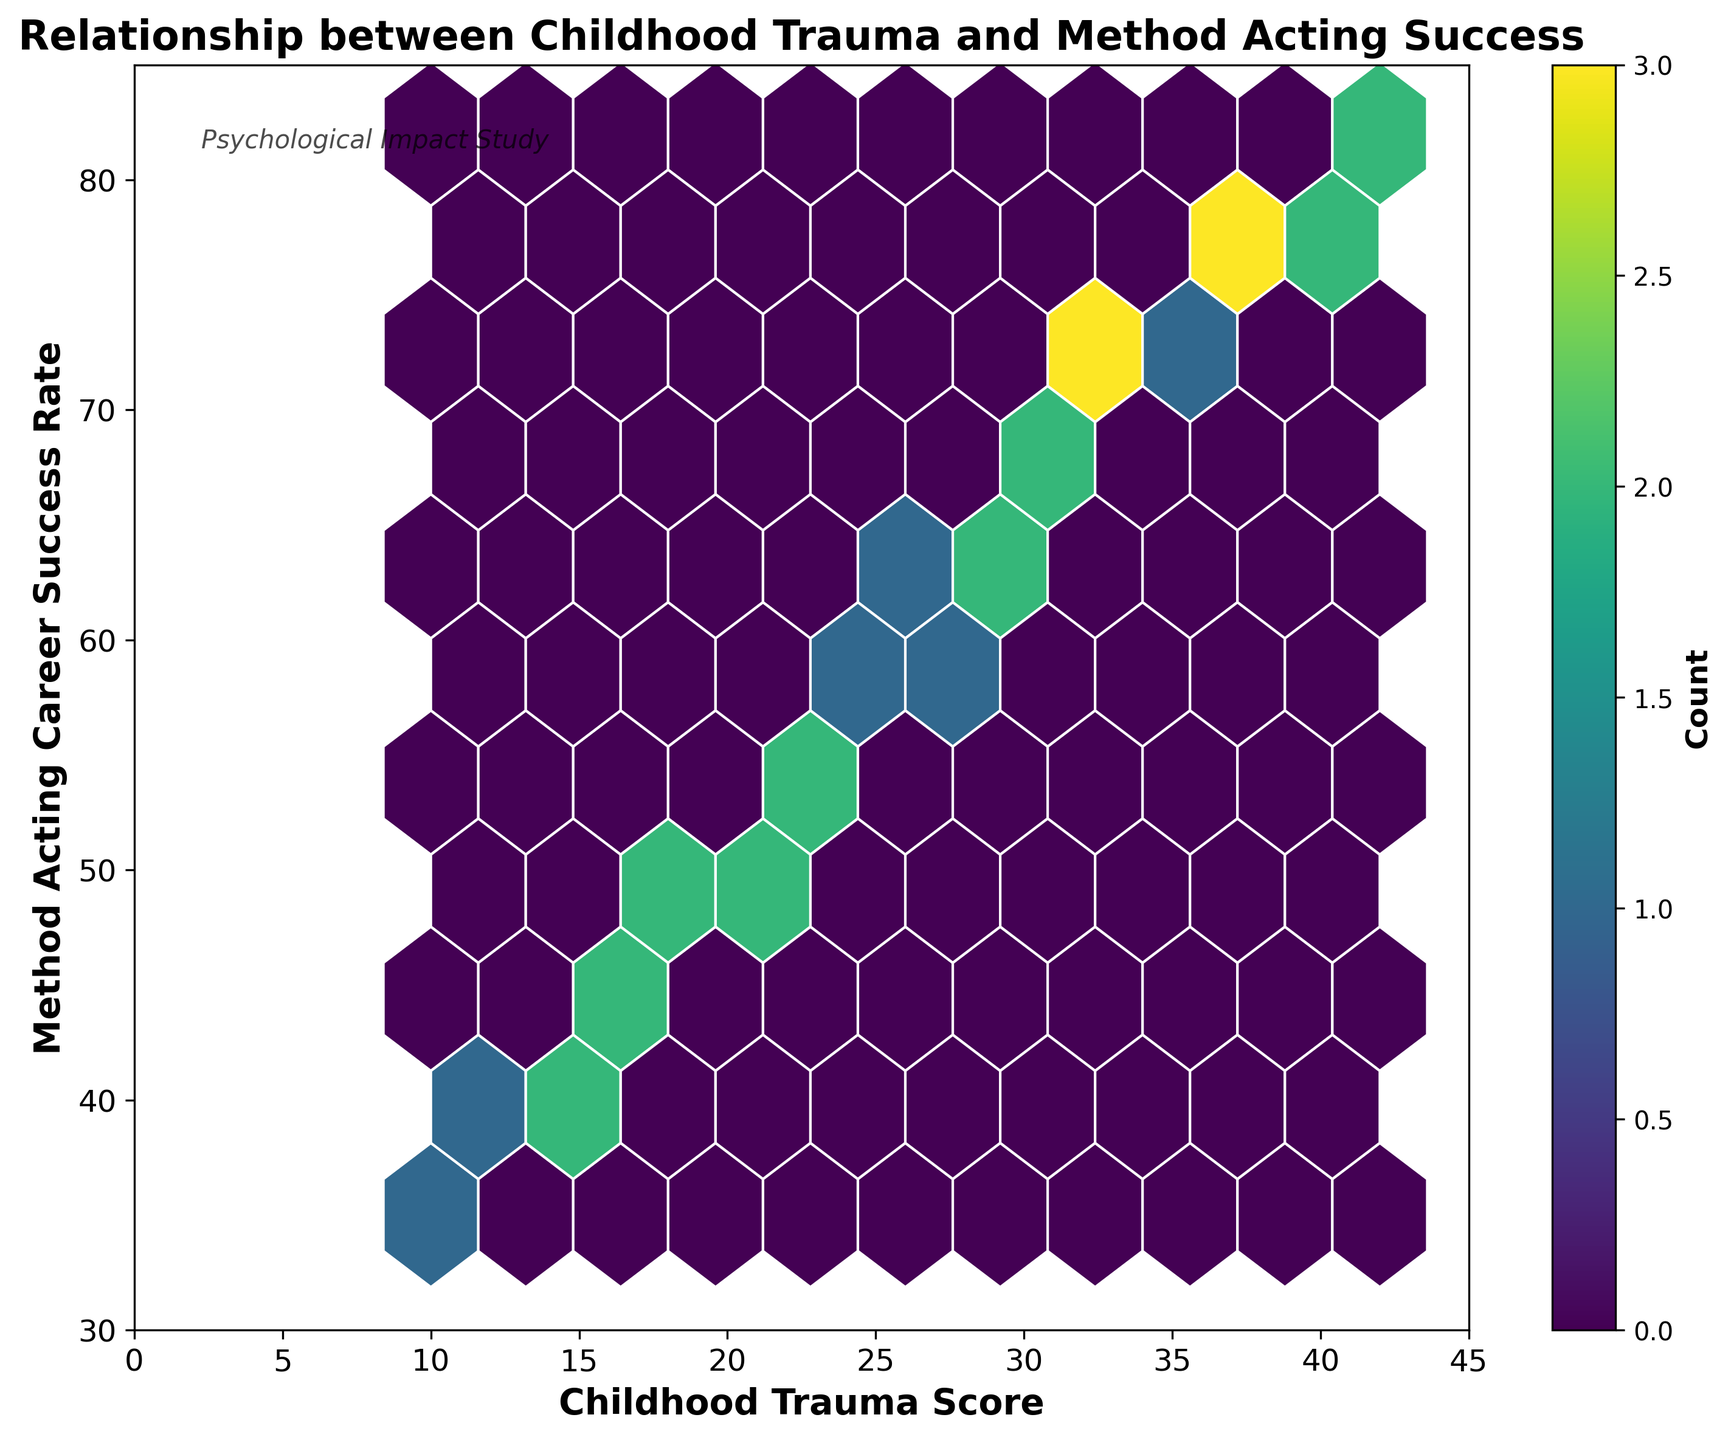What is the title of the figure? The title is displayed at the top of the figure. It gives an overview of what the plot represents.
Answer: Relationship between Childhood Trauma and Method Acting Success What color is used in the hexbin plot to show higher densities of data points? The hexbin plot uses a color gradient where darker colors indicate higher densities. In this plot, the color transitions from lighter to darker shades of green, with the darkest areas showing the highest densities.
Answer: Dark green What is the range of Childhood Trauma Scores on the x-axis? The x-axis labels indicate the range of values for Childhood Trauma Scores that the plot covers. The axis starts at 0 and ends at 45, as shown by the tick marks.
Answer: 0 to 45 Where on the plot do the highest densities of data points appear? By looking at the darkest colored hexagons on the plot, we can identify areas of the plot where data points are most concentrated. These are around the middle values of Childhood Trauma Scores and Method Acting Career Success Rates.
Answer: Around Childhood Trauma Scores of 30 and Method Acting Career Success Rates of 70 Is there a positive correlation between Childhood Trauma Score and Method Acting Career Success Rate? By examining the general trend of the data points and noting that higher Childhood Trauma Scores tend to be associated with higher Method Acting Career Success Rates, one can infer a positive correlation.
Answer: Yes What is the average Method Acting Career Success Rate for a Childhood Trauma Score of 20? Identify the hexagons corresponding to a Childhood Trauma Score of 20, then estimate the average success rate by averaging the y-values centered within those hexagons.
Answer: Approximately 50 How many data points are included in the highest density hexbin? The color bar indicates the count of data points represented by each color. The highest density hexagon is the darkest green and the color bar shows that it represents around 2-3 data points.
Answer: 2-3 Which has a wider spread on the hexbin plot, Childhood Trauma Scores or Method Acting Career Success Rates? By comparing the spread of hexagons along the x-axis (Childhood Trauma Scores) and y-axis (Method Acting Career Success Rates), we can determine which variable has a wider range of values in the plot.
Answer: Childhood Trauma Scores What is the label on the color bar? The color bar to the right of the plot indicates the number of data points represented by the color. The label on this color bar is displayed at the top or bottom.
Answer: Count Does the plot indicate any outliers in the data? If yes, where are they located? Outliers are data points that fall outside the general trend of the data. By identifying isolated hexagons that do not conform to the overall pattern, we can locate any outliers. In this plot, there are no clear isolated hexagons visible.
Answer: No, there are no clear outliers 